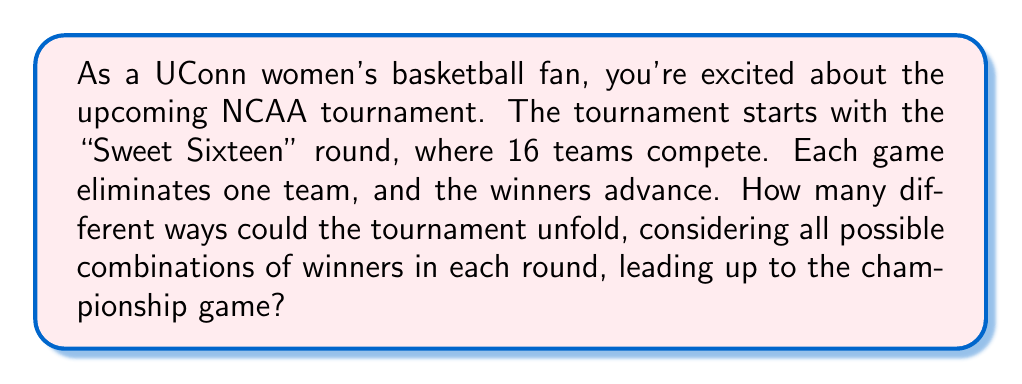Teach me how to tackle this problem. Let's break this down step-by-step, thinking of it like the plot twists in a thrilling basketball novel:

1. In the Sweet Sixteen round, we have 8 games. Each game has 2 possible outcomes (either team could win). This is like having 8 independent coin flips.

2. For the Elite Eight, we'll have 4 games, then 2 games for the Final Four, and finally 1 championship game.

3. In probability, when we have independent events, we multiply the number of possibilities for each event. Here's how it plays out:

   - Sweet Sixteen: $2^8$ possibilities (8 games, 2 choices each)
   - Elite Eight: $2^4$ possibilities (4 games, 2 choices each)
   - Final Four: $2^2$ possibilities (2 games, 2 choices each)
   - Championship: $2^1$ possibilities (1 game, 2 choices)

4. To get the total number of ways the tournament could unfold, we multiply these together:

   $$ \text{Total possibilities} = 2^8 \times 2^4 \times 2^2 \times 2^1 $$

5. Using the laws of exponents, we can simplify this:

   $$ \text{Total possibilities} = 2^{8+4+2+1} = 2^{15} $$

6. Calculating this out: $2^{15} = 32,768$

So, just like how a great author can create countless plot twists, the tournament has tens of thousands of possible outcomes!
Answer: $32,768$ possible outcomes 